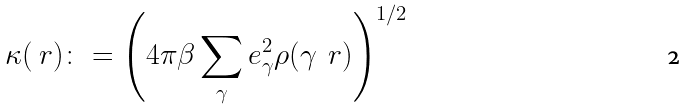Convert formula to latex. <formula><loc_0><loc_0><loc_500><loc_500>\kappa ( \ r ) \colon = \left ( 4 \pi \beta \sum _ { \gamma } e _ { \gamma } ^ { 2 } \rho ( \gamma \, \ r ) \right ) ^ { 1 / 2 }</formula> 